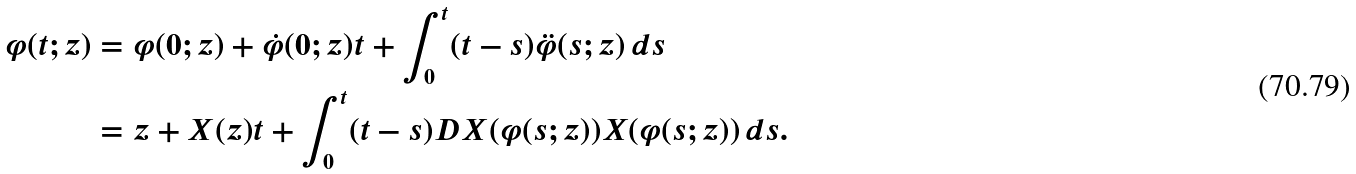Convert formula to latex. <formula><loc_0><loc_0><loc_500><loc_500>\varphi ( t ; z ) & = \varphi ( 0 ; z ) + \dot { \varphi } ( 0 ; z ) t + \int _ { 0 } ^ { t } ( t - s ) \ddot { \varphi } ( s ; z ) \, d s \\ & = z + X ( z ) t + \int _ { 0 } ^ { t } ( t - s ) D X ( \varphi ( s ; z ) ) X ( \varphi ( s ; z ) ) \, d s .</formula> 